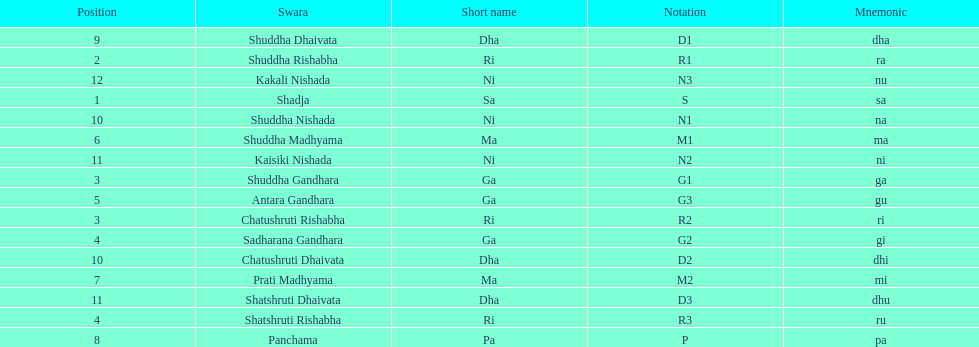Which swara holds the last position? Kakali Nishada. 